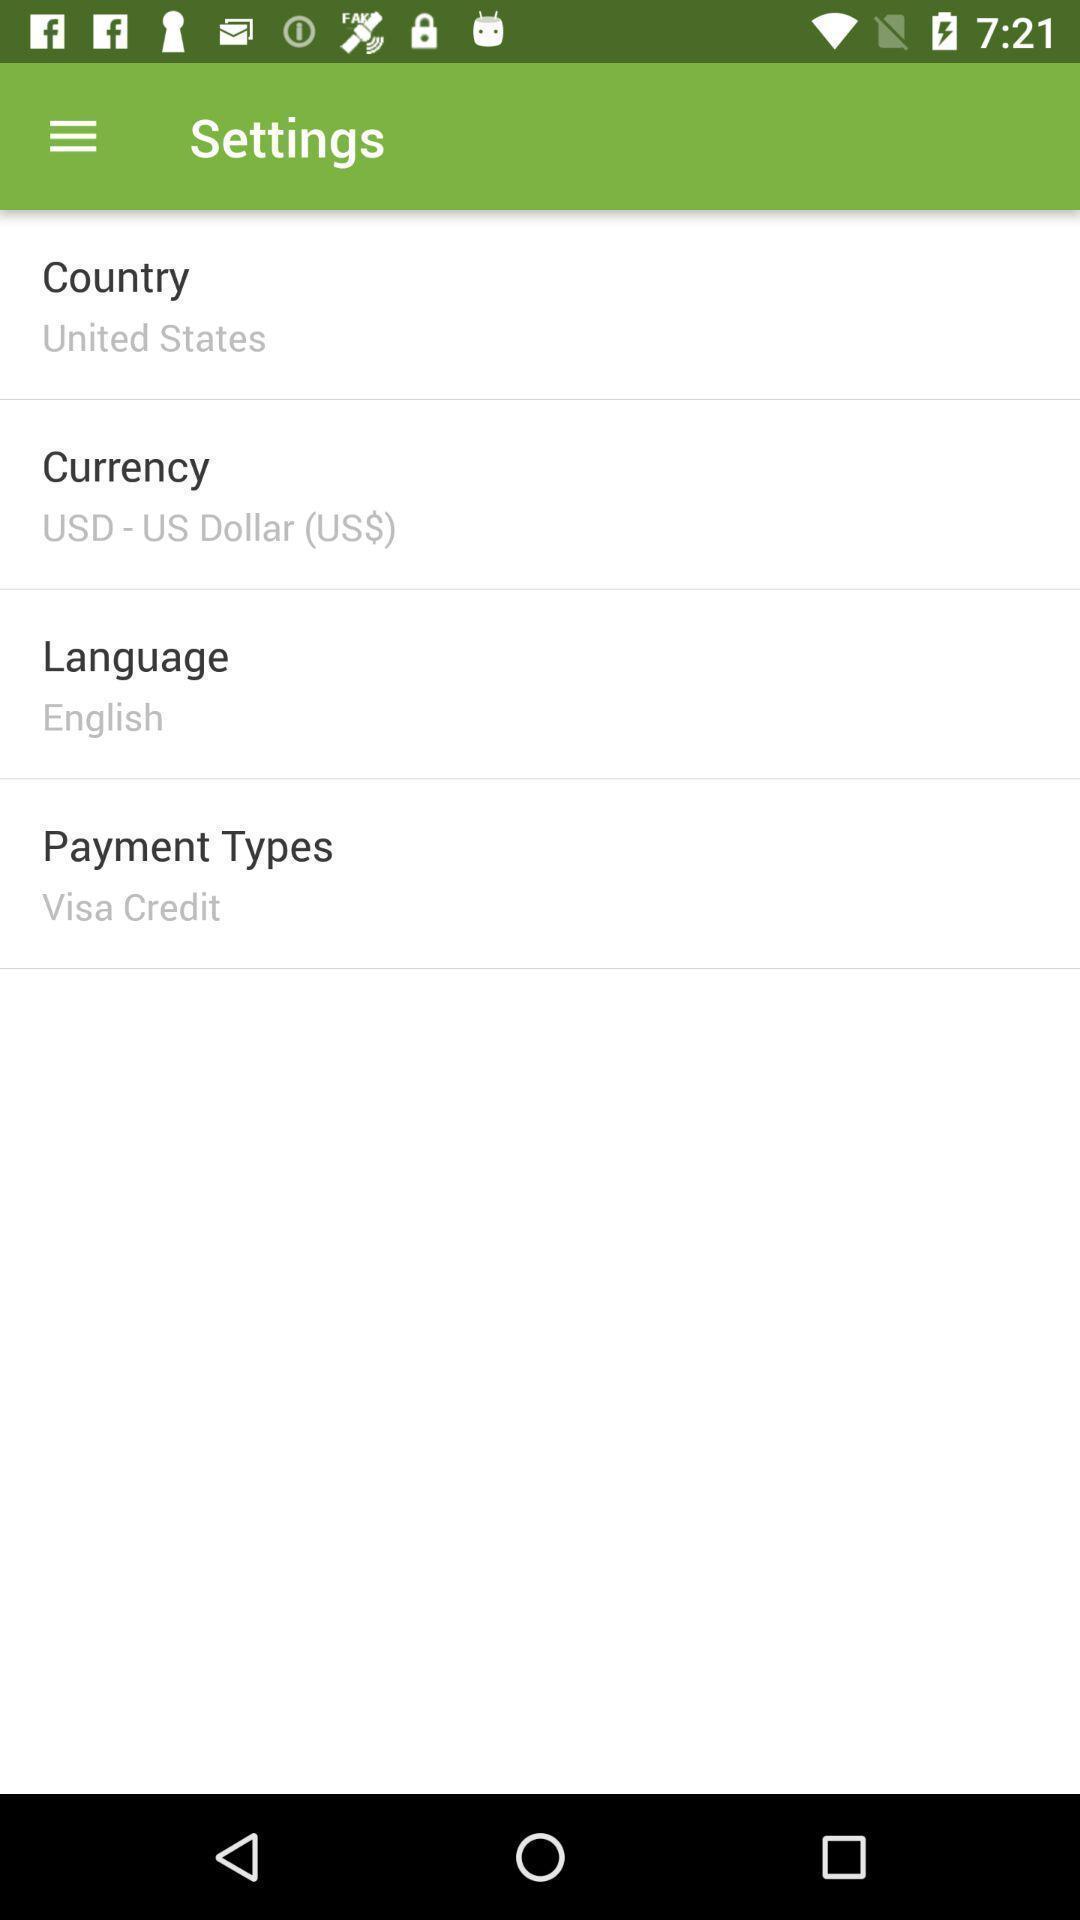What can you discern from this picture? Settings page of the reservation app. 